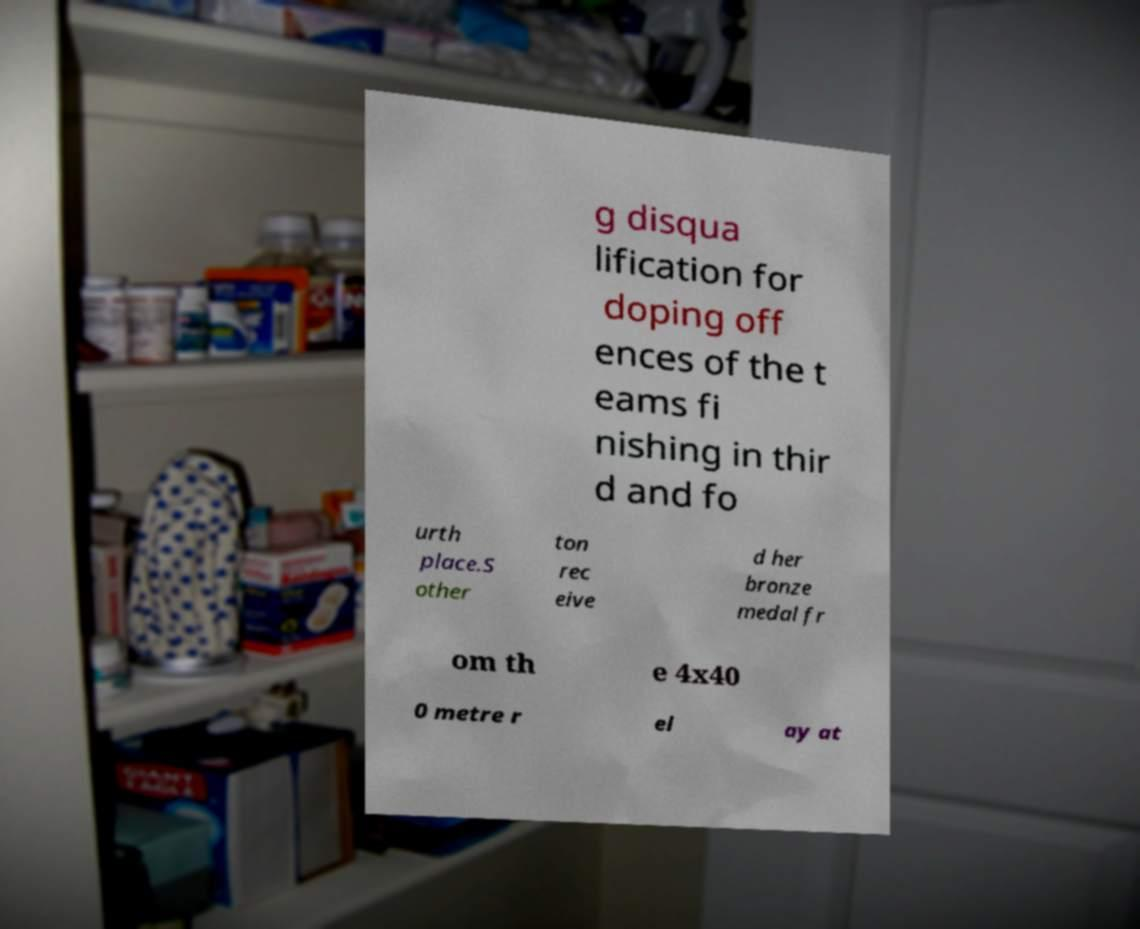I need the written content from this picture converted into text. Can you do that? g disqua lification for doping off ences of the t eams fi nishing in thir d and fo urth place.S other ton rec eive d her bronze medal fr om th e 4x40 0 metre r el ay at 